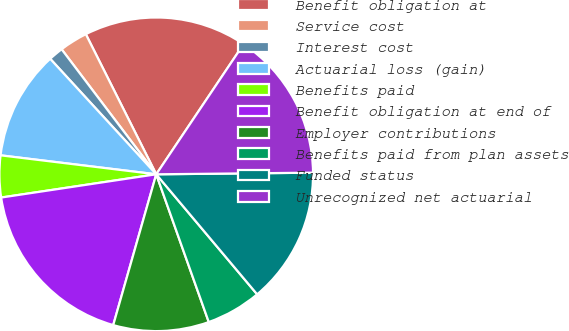<chart> <loc_0><loc_0><loc_500><loc_500><pie_chart><fcel>Benefit obligation at<fcel>Service cost<fcel>Interest cost<fcel>Actuarial loss (gain)<fcel>Benefits paid<fcel>Benefit obligation at end of<fcel>Employer contributions<fcel>Benefits paid from plan assets<fcel>Funded status<fcel>Unrecognized net actuarial<nl><fcel>16.82%<fcel>2.9%<fcel>1.51%<fcel>11.25%<fcel>4.3%<fcel>18.21%<fcel>9.86%<fcel>5.69%<fcel>14.04%<fcel>15.43%<nl></chart> 